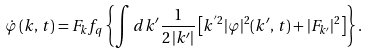Convert formula to latex. <formula><loc_0><loc_0><loc_500><loc_500>\dot { \varphi } \, ( k , \, t ) = F _ { k } f _ { q } \left \{ \int d k ^ { \prime } \frac { 1 } { 2 \, | k ^ { \prime } | } \left [ k ^ { ^ { \prime } 2 } | \varphi | ^ { 2 } ( k ^ { \prime } , \, t ) + | F _ { k ^ { \prime } } | ^ { 2 } \right ] \right \} .</formula> 